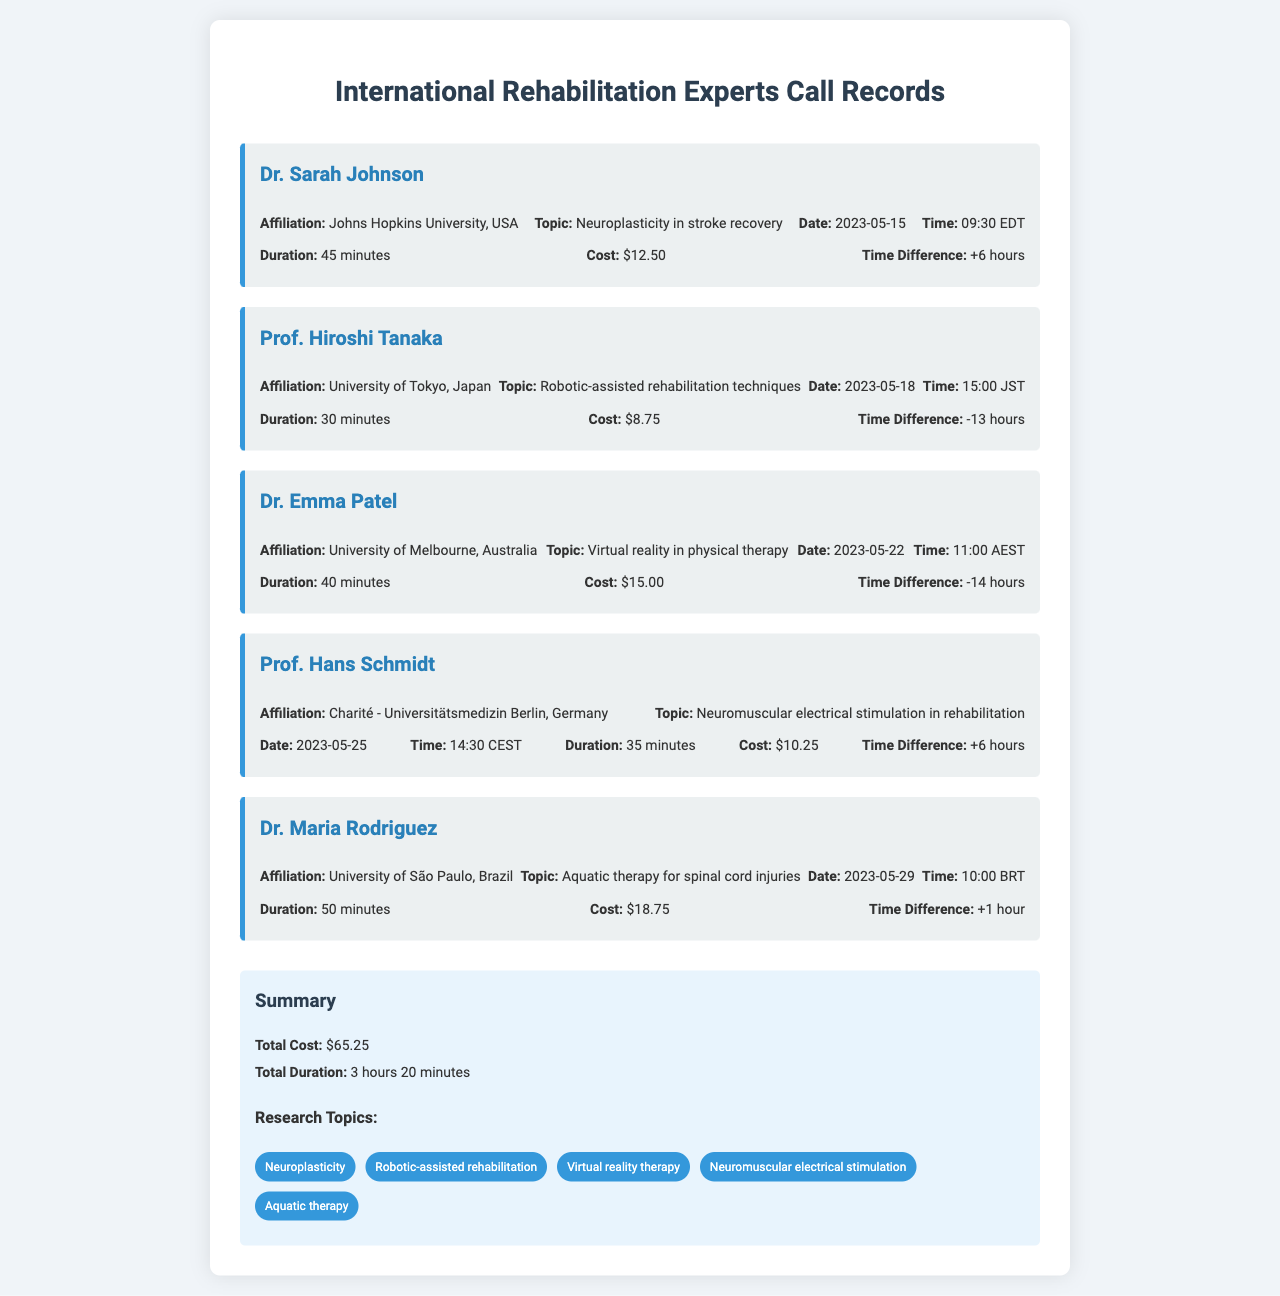What is the total cost of all calls? The total cost is listed in the summary section, which sums up to $65.25.
Answer: $65.25 Who did Dr. Sarah Johnson represent? Dr. Sarah Johnson's affiliation is provided in the call record, which is Johns Hopkins University, USA.
Answer: Johns Hopkins University, USA What was the duration of the call with Dr. Maria Rodriguez? The duration of the call is stated in Dr. Maria Rodriguez's call record, which is 50 minutes.
Answer: 50 minutes What topic did Prof. Hiroshi Tanaka discuss? The topic discussed in Prof. Hiroshi Tanaka's call record is Robotic-assisted rehabilitation techniques.
Answer: Robotic-assisted rehabilitation techniques What time was the call with Dr. Emma Patel in AEST? The time of the call is specified in Dr. Emma Patel's record, occurring at 11:00 AEST.
Answer: 11:00 AEST How many different research topics are mentioned? The number of unique research topics is listed in the summary section, which includes five different topics.
Answer: 5 What is the time difference for calls with Dr. Sarah Johnson? The time difference for Dr. Sarah Johnson's call is stated as +6 hours.
Answer: +6 hours Which expert discussed aquatic therapy? The call record mentions that Dr. Maria Rodriguez talked about aquatic therapy for spinal cord injuries.
Answer: Dr. Maria Rodriguez 